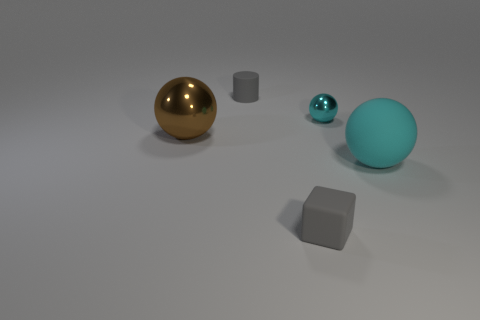Add 2 cyan rubber cubes. How many objects exist? 7 Subtract all blocks. How many objects are left? 4 Subtract all gray matte balls. Subtract all small matte objects. How many objects are left? 3 Add 1 gray rubber cylinders. How many gray rubber cylinders are left? 2 Add 5 big blocks. How many big blocks exist? 5 Subtract 0 cyan cubes. How many objects are left? 5 